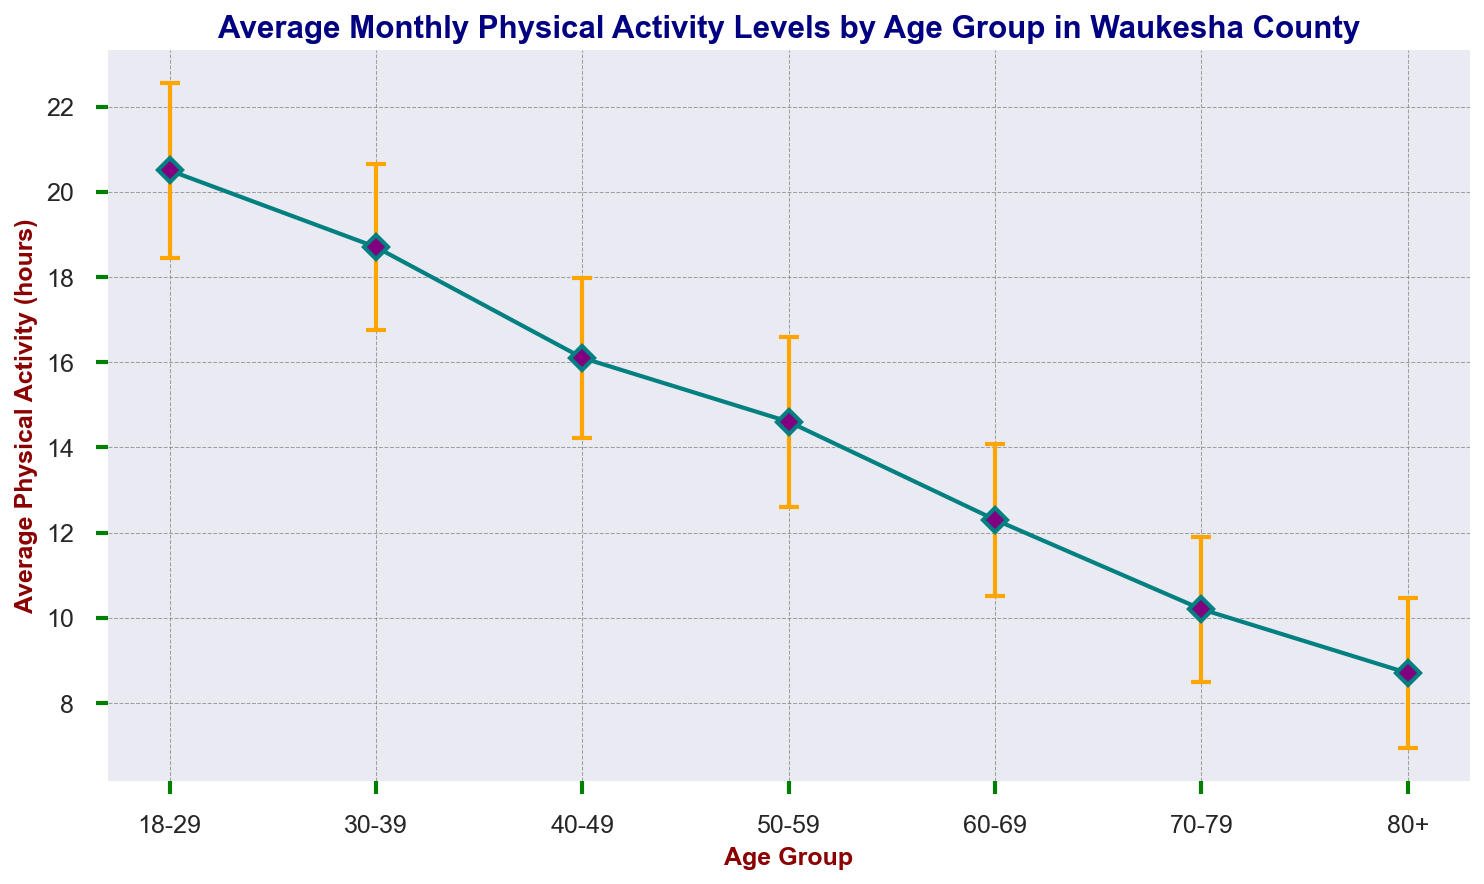How does physical activity change as the age group increases? As we move from younger to older age groups, the average monthly physical activity consistently decreases. For instance, those in the 18-29 age group engage in about 20.5 hours of activity per month, whereas those in the 80+ age group only engage in about 8.7 hours per month. This trend indicates a clear decline in physical activity with increasing age.
Answer: It decreases Which age group has the least variation in their average monthly physical activity levels? The level of variation can be determined by looking at the variance values. The 70-79 age group has the lowest variance at 2.9, indicating the least variation in their physical activity levels among the age groups.
Answer: 70-79 By how much does the physical activity level of the 18-29 age group exceed that of the 60-69 age group? The physical activity level of the 18-29 age group is 20.5 hours, and for the 60-69 age group, it is 12.3 hours. The difference is calculated as 20.5 - 12.3 = 8.2 hours.
Answer: 8.2 hours What is the total variance for all age groups combined? Adding up the variance for each age group: 4.2 (18-29) + 3.8 (30-39) + 3.5 (40-49) + 4.0 (50-59) + 3.2 (60-69) + 2.9 (70-79) + 3.1 (80+), the total variance is 24.7.
Answer: 24.7 Which age group shows the steepest decline in average monthly physical activity compared to the previous age group? The decline can be measured by comparing the differences between each consecutive age group. The sharpest decline is between the 60-69 age group (12.3 hours) and the 70-79 age group (10.2 hours), a difference of 2.1 hours.
Answer: 60-69 to 70-79 Is there a larger variance in physical activity levels for the 50-59 age group or the 30-39 age group? Comparing the variance values: the 50-59 age group has a variance of 4.0, while the 30-39 age group has a variance of 3.8. Therefore, the 50-59 age group has a slightly larger variance.
Answer: 50-59 What's the average of the average monthly physical activity hours across all age groups? Adding up all the average monthly physical activity hours: 20.5 + 18.7 + 16.1 + 14.6 + 12.3 + 10.2 + 8.7 = 101.1 hours. Dividing this sum by the number of age groups (7), the average is 101.1 / 7 ≈ 14.44 hours.
Answer: 14.44 hours 